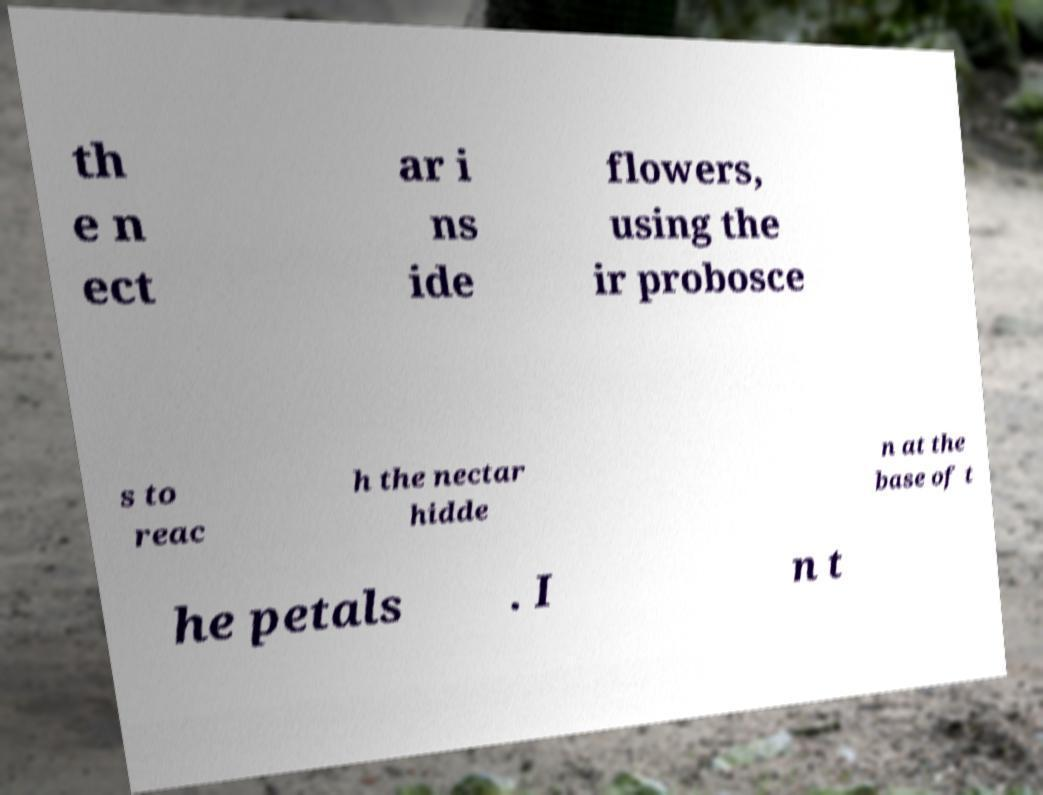For documentation purposes, I need the text within this image transcribed. Could you provide that? th e n ect ar i ns ide flowers, using the ir probosce s to reac h the nectar hidde n at the base of t he petals . I n t 